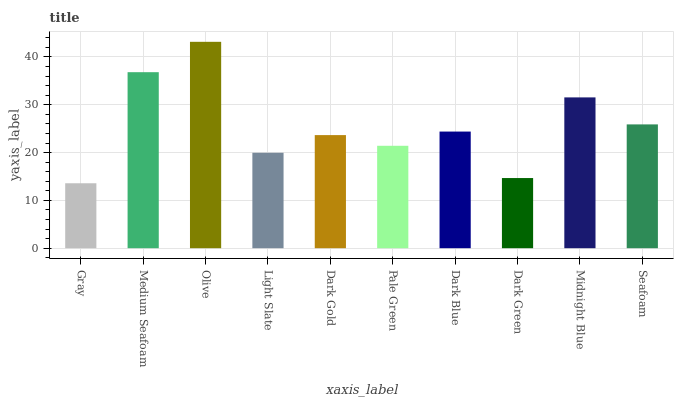Is Gray the minimum?
Answer yes or no. Yes. Is Olive the maximum?
Answer yes or no. Yes. Is Medium Seafoam the minimum?
Answer yes or no. No. Is Medium Seafoam the maximum?
Answer yes or no. No. Is Medium Seafoam greater than Gray?
Answer yes or no. Yes. Is Gray less than Medium Seafoam?
Answer yes or no. Yes. Is Gray greater than Medium Seafoam?
Answer yes or no. No. Is Medium Seafoam less than Gray?
Answer yes or no. No. Is Dark Blue the high median?
Answer yes or no. Yes. Is Dark Gold the low median?
Answer yes or no. Yes. Is Seafoam the high median?
Answer yes or no. No. Is Dark Blue the low median?
Answer yes or no. No. 